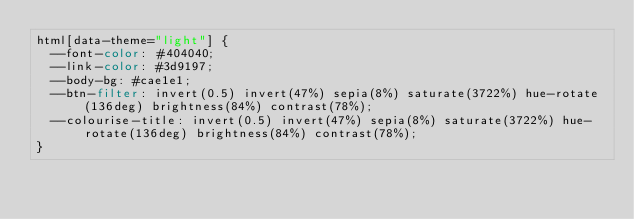<code> <loc_0><loc_0><loc_500><loc_500><_CSS_>html[data-theme="light"] {
  --font-color: #404040;
  --link-color: #3d9197;
  --body-bg: #cae1e1;
  --btn-filter: invert(0.5) invert(47%) sepia(8%) saturate(3722%) hue-rotate(136deg) brightness(84%) contrast(78%);
  --colourise-title: invert(0.5) invert(47%) sepia(8%) saturate(3722%) hue-rotate(136deg) brightness(84%) contrast(78%);
}
</code> 